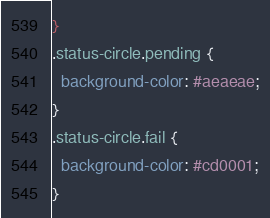<code> <loc_0><loc_0><loc_500><loc_500><_CSS_>}
.status-circle.pending {
  background-color: #aeaeae;
}
.status-circle.fail {
  background-color: #cd0001;
}
</code> 